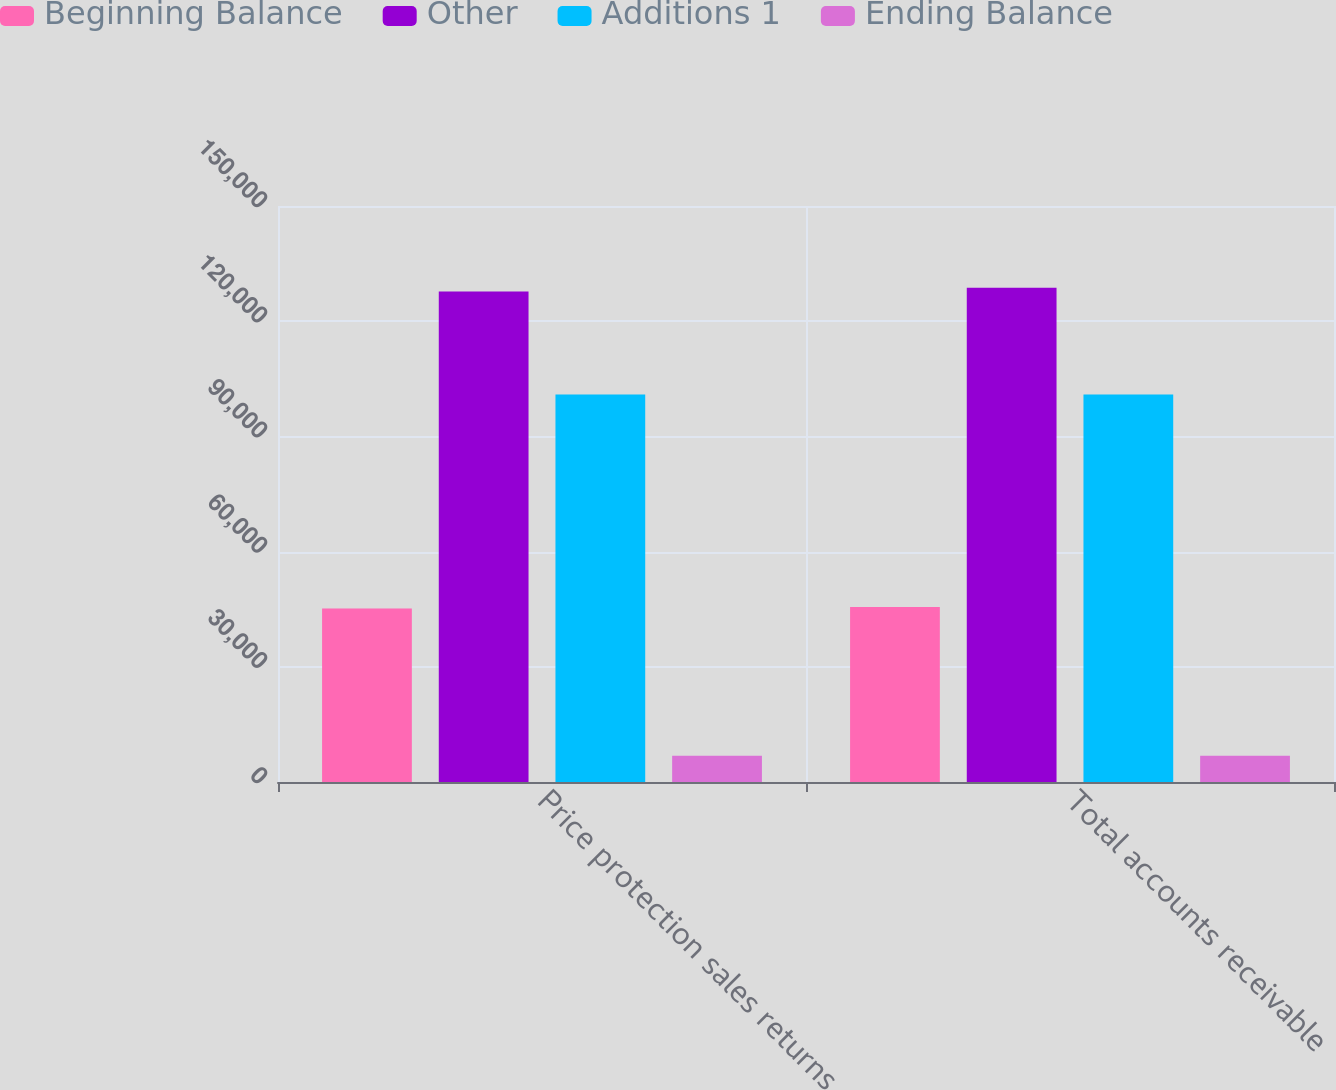Convert chart to OTSL. <chart><loc_0><loc_0><loc_500><loc_500><stacked_bar_chart><ecel><fcel>Price protection sales returns<fcel>Total accounts receivable<nl><fcel>Beginning Balance<fcel>45153<fcel>45552<nl><fcel>Other<fcel>127744<fcel>128718<nl><fcel>Additions 1<fcel>100934<fcel>100938<nl><fcel>Ending Balance<fcel>6849<fcel>6849<nl></chart> 